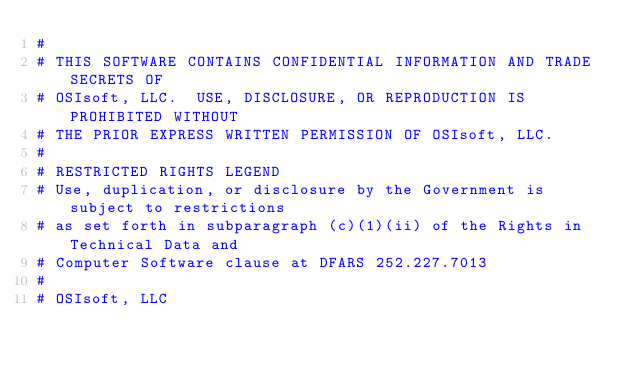<code> <loc_0><loc_0><loc_500><loc_500><_Python_>#
# THIS SOFTWARE CONTAINS CONFIDENTIAL INFORMATION AND TRADE SECRETS OF
# OSIsoft, LLC.  USE, DISCLOSURE, OR REPRODUCTION IS PROHIBITED WITHOUT
# THE PRIOR EXPRESS WRITTEN PERMISSION OF OSIsoft, LLC.
#
# RESTRICTED RIGHTS LEGEND
# Use, duplication, or disclosure by the Government is subject to restrictions
# as set forth in subparagraph (c)(1)(ii) of the Rights in Technical Data and
# Computer Software clause at DFARS 252.227.7013
#
# OSIsoft, LLC</code> 